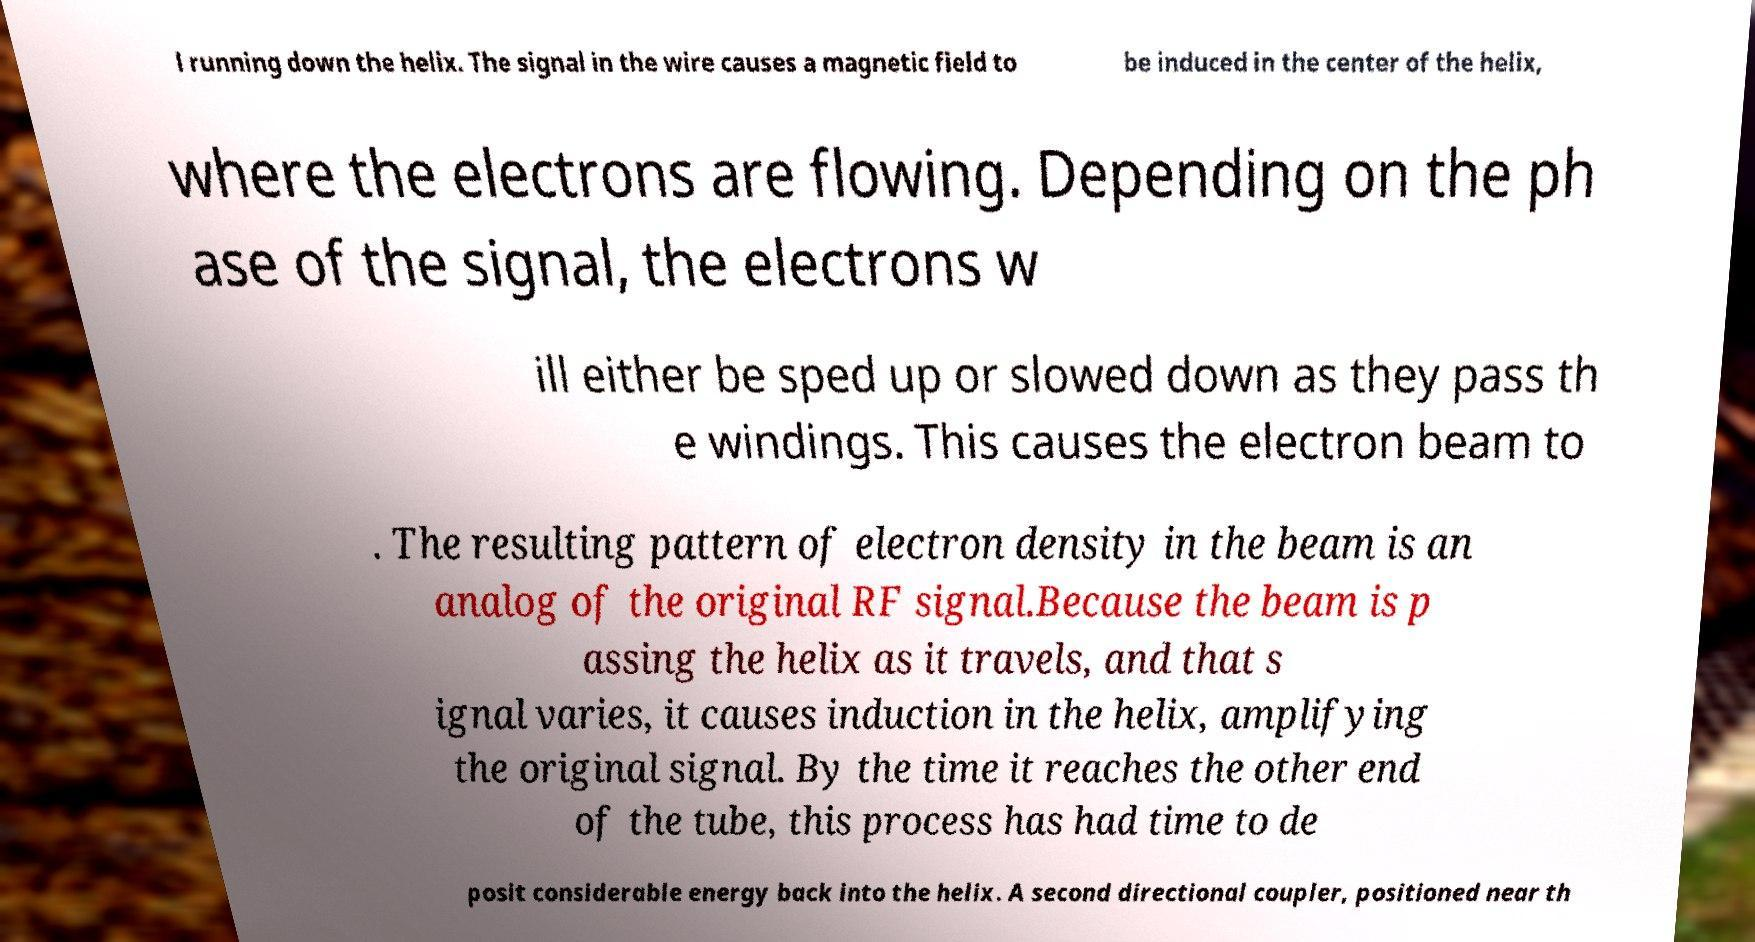Please identify and transcribe the text found in this image. l running down the helix. The signal in the wire causes a magnetic field to be induced in the center of the helix, where the electrons are flowing. Depending on the ph ase of the signal, the electrons w ill either be sped up or slowed down as they pass th e windings. This causes the electron beam to . The resulting pattern of electron density in the beam is an analog of the original RF signal.Because the beam is p assing the helix as it travels, and that s ignal varies, it causes induction in the helix, amplifying the original signal. By the time it reaches the other end of the tube, this process has had time to de posit considerable energy back into the helix. A second directional coupler, positioned near th 